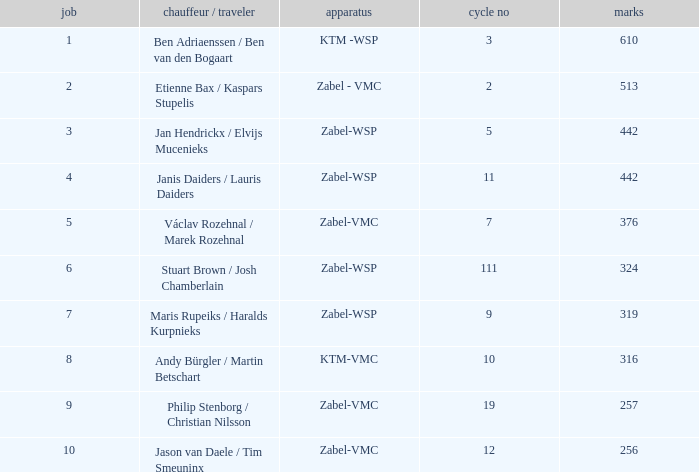Could you help me parse every detail presented in this table? {'header': ['job', 'chauffeur / traveler', 'apparatus', 'cycle no', 'marks'], 'rows': [['1', 'Ben Adriaenssen / Ben van den Bogaart', 'KTM -WSP', '3', '610'], ['2', 'Etienne Bax / Kaspars Stupelis', 'Zabel - VMC', '2', '513'], ['3', 'Jan Hendrickx / Elvijs Mucenieks', 'Zabel-WSP', '5', '442'], ['4', 'Janis Daiders / Lauris Daiders', 'Zabel-WSP', '11', '442'], ['5', 'Václav Rozehnal / Marek Rozehnal', 'Zabel-VMC', '7', '376'], ['6', 'Stuart Brown / Josh Chamberlain', 'Zabel-WSP', '111', '324'], ['7', 'Maris Rupeiks / Haralds Kurpnieks', 'Zabel-WSP', '9', '319'], ['8', 'Andy Bürgler / Martin Betschart', 'KTM-VMC', '10', '316'], ['9', 'Philip Stenborg / Christian Nilsson', 'Zabel-VMC', '19', '257'], ['10', 'Jason van Daele / Tim Smeuninx', 'Zabel-VMC', '12', '256']]} What is the Equipment that has a Point bigger than 256, and a Position of 3? Zabel-WSP. 